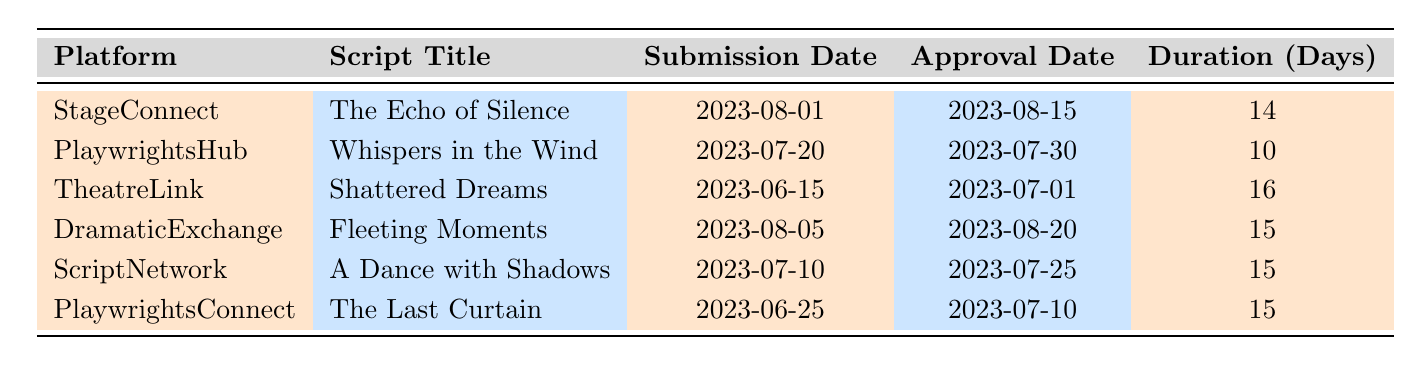What is the title of the script submitted on August 1, 2023? The table indicates that the script submitted on August 1, 2023, is titled "The Echo of Silence."
Answer: The Echo of Silence Which platform had the longest approval duration? The approval durations for each platform are 14, 10, 16, 15, 15, and 15 days, respectively. The longest duration is 16 days from TheatreLink for the script "Shattered Dreams."
Answer: TheatreLink Did the script "Fleeting Moments" get approved faster than "Whispers in the Wind"? "Fleeting Moments" submitted on August 5, 2023, was approved in 15 days. "Whispers in the Wind," submitted on July 20, 2023, was approved in 10 days. Therefore, "Whispers in the Wind" was approved faster.
Answer: No What is the average approval duration for all scripts listed? The durations are 14, 10, 16, 15, 15, and 15 days. Summing these gives 14 + 10 + 16 + 15 + 15 + 15 = 85. There are 6 scripts, so the average is 85 / 6 ≈ 14.17 days.
Answer: 14.17 Which script was approved on July 30, 2023? By checking the approval dates in the table, “Whispers in the Wind” was approved on July 30, 2023.
Answer: Whispers in the Wind How many days did “The Last Curtain” take for approval? The table shows that “The Last Curtain” took 15 days for approval.
Answer: 15 What is the difference in approval duration between "Shattered Dreams" and "Fleeting Moments"? "Shattered Dreams" took 16 days and "Fleeting Moments" took 15 days. The difference is 16 - 15 = 1 day.
Answer: 1 day Is there any script that was approved in less than 15 days? The table shows that the only script approved in less than 15 days is "Whispers in the Wind" which took 10 days.
Answer: Yes 